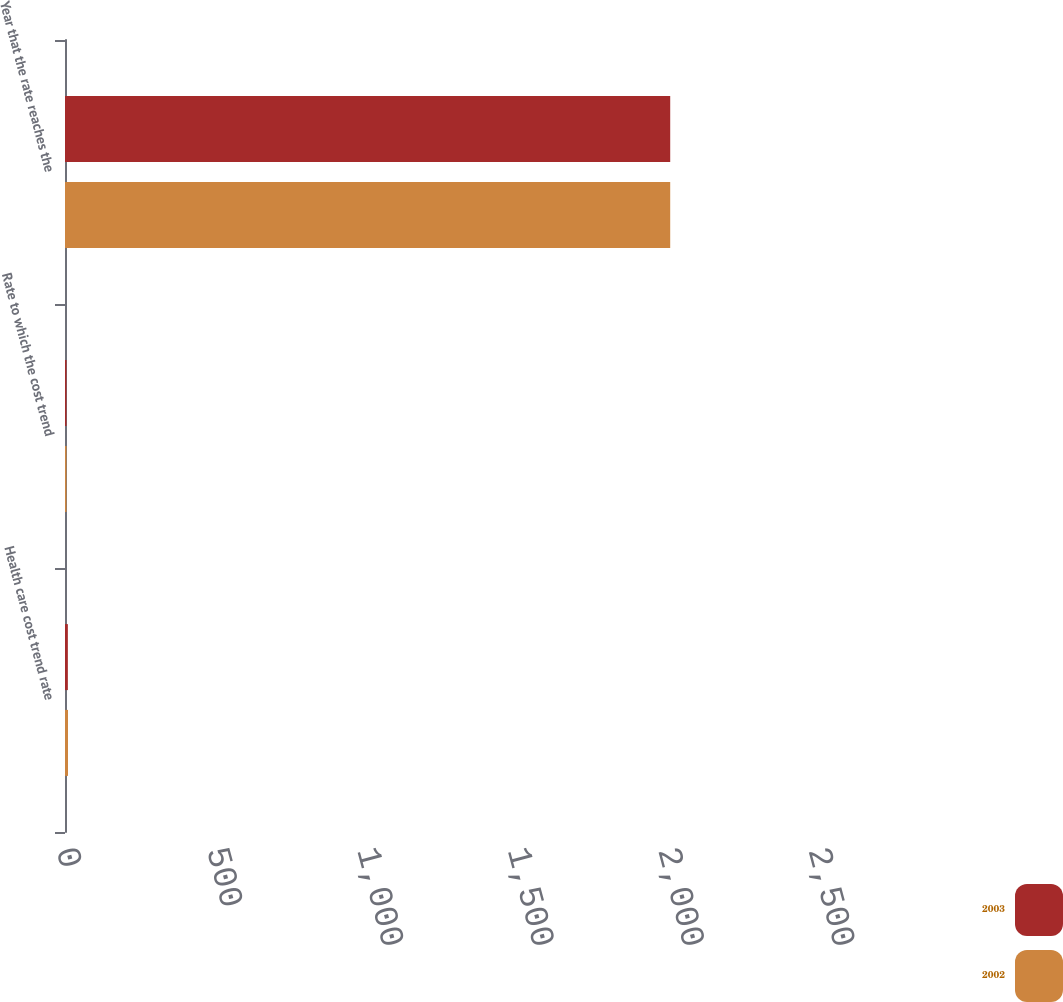<chart> <loc_0><loc_0><loc_500><loc_500><stacked_bar_chart><ecel><fcel>Health care cost trend rate<fcel>Rate to which the cost trend<fcel>Year that the rate reaches the<nl><fcel>2003<fcel>9.5<fcel>5<fcel>2012<nl><fcel>2002<fcel>10<fcel>5<fcel>2012<nl></chart> 